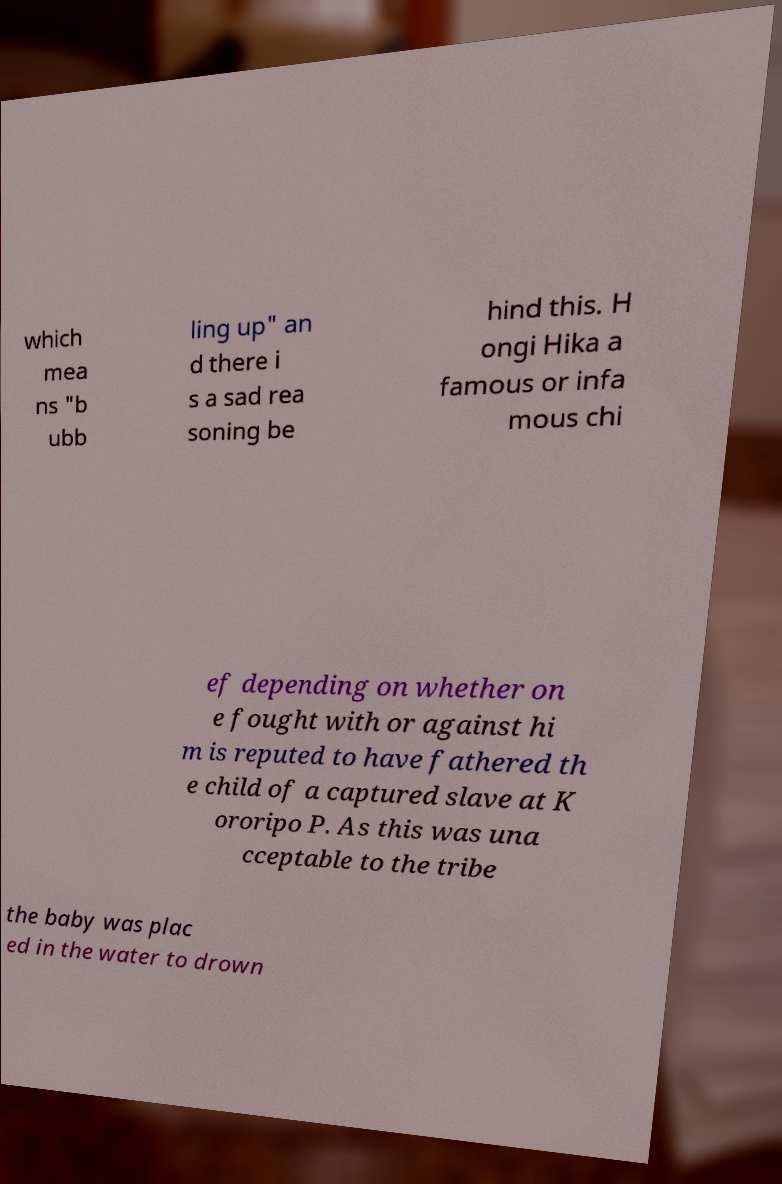For documentation purposes, I need the text within this image transcribed. Could you provide that? which mea ns "b ubb ling up" an d there i s a sad rea soning be hind this. H ongi Hika a famous or infa mous chi ef depending on whether on e fought with or against hi m is reputed to have fathered th e child of a captured slave at K ororipo P. As this was una cceptable to the tribe the baby was plac ed in the water to drown 